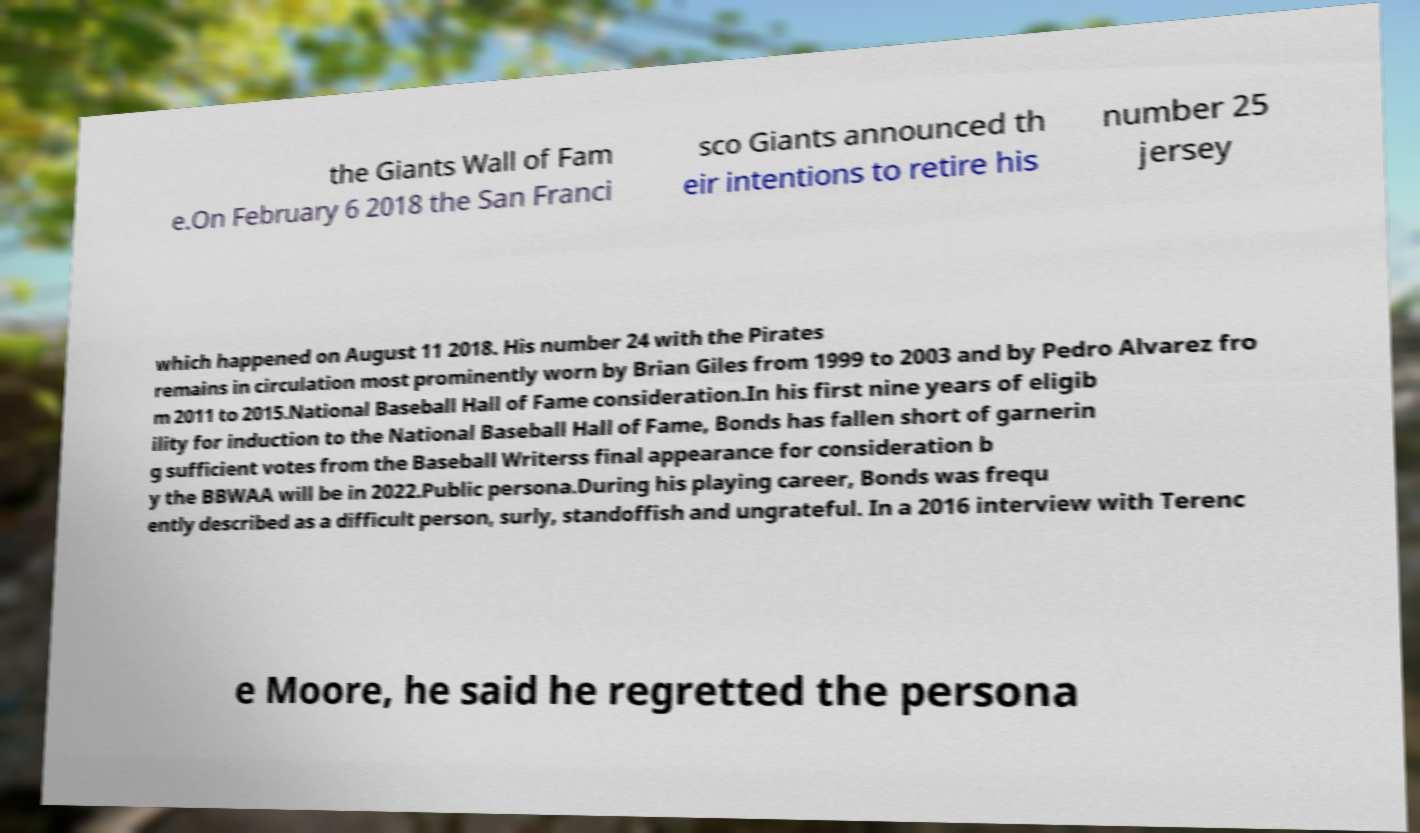What messages or text are displayed in this image? I need them in a readable, typed format. the Giants Wall of Fam e.On February 6 2018 the San Franci sco Giants announced th eir intentions to retire his number 25 jersey which happened on August 11 2018. His number 24 with the Pirates remains in circulation most prominently worn by Brian Giles from 1999 to 2003 and by Pedro Alvarez fro m 2011 to 2015.National Baseball Hall of Fame consideration.In his first nine years of eligib ility for induction to the National Baseball Hall of Fame, Bonds has fallen short of garnerin g sufficient votes from the Baseball Writerss final appearance for consideration b y the BBWAA will be in 2022.Public persona.During his playing career, Bonds was frequ ently described as a difficult person, surly, standoffish and ungrateful. In a 2016 interview with Terenc e Moore, he said he regretted the persona 